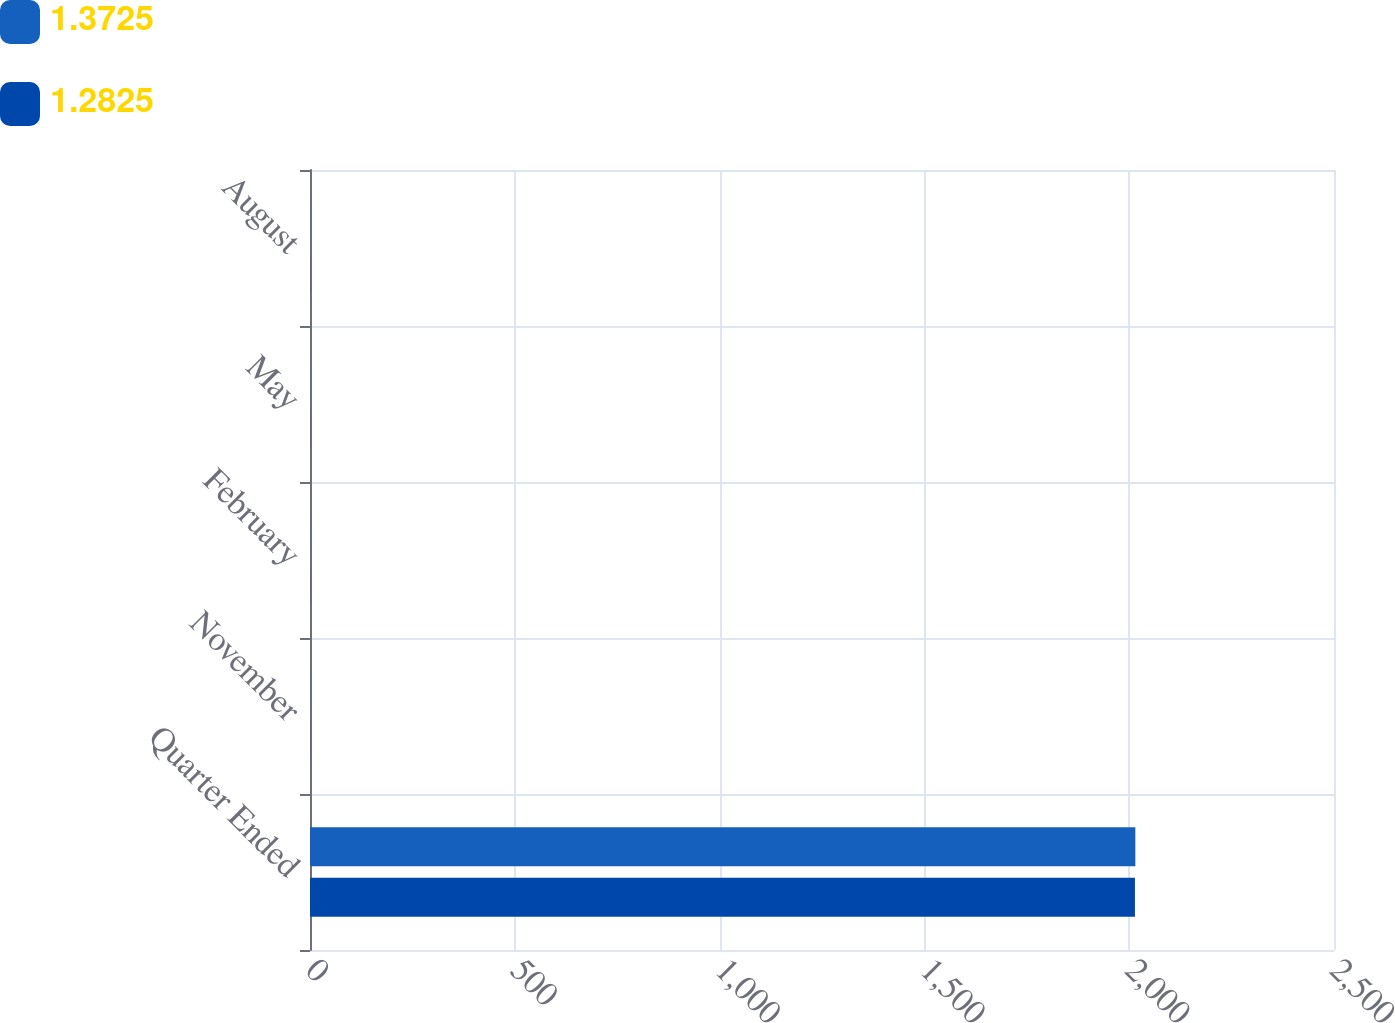Convert chart to OTSL. <chart><loc_0><loc_0><loc_500><loc_500><stacked_bar_chart><ecel><fcel>Quarter Ended<fcel>November<fcel>February<fcel>May<fcel>August<nl><fcel>1.3725<fcel>2015<fcel>0.34<fcel>0.34<fcel>0.34<fcel>0.36<nl><fcel>1.2825<fcel>2014<fcel>0.32<fcel>0.32<fcel>0.32<fcel>0.34<nl></chart> 